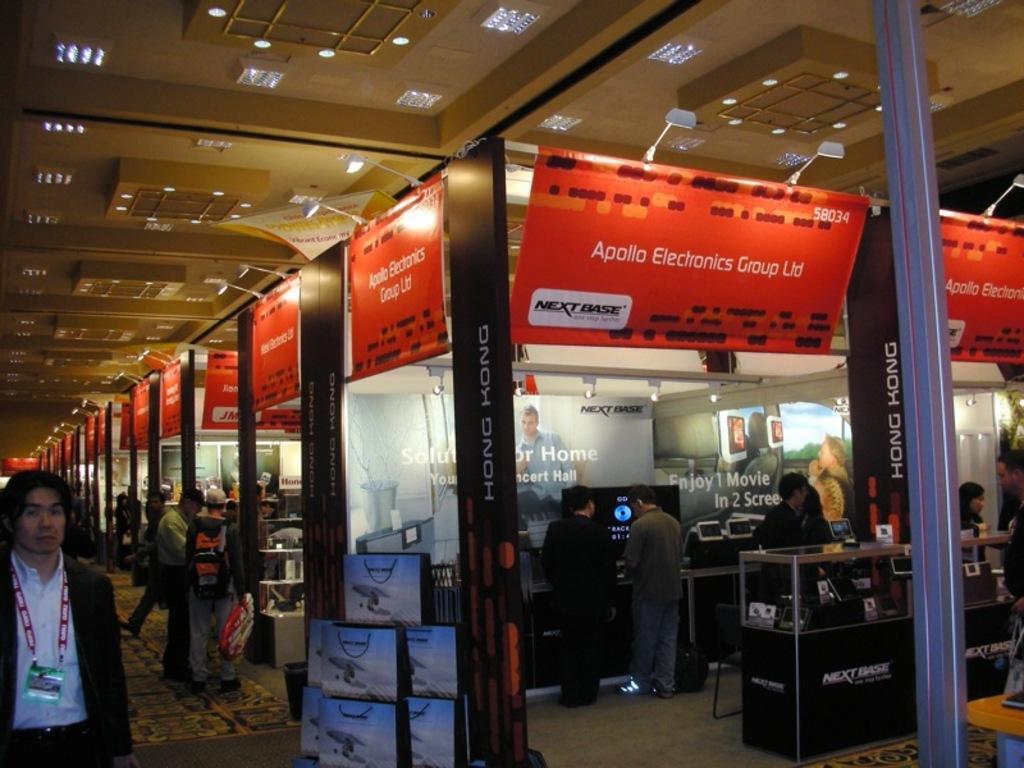Please provide a concise description of this image. On the left side of the picture, we see man standing. Beside them, we see stalls or rooms. At the top of the picture, we see red color hoarding boards with some text written on it. On the right side, we see a table in black color. We even see men are standing. At the top of the picture, we see the ceiling of the room. This picture is clicked inside the room. At the bottom of the picture, we see the bags. 